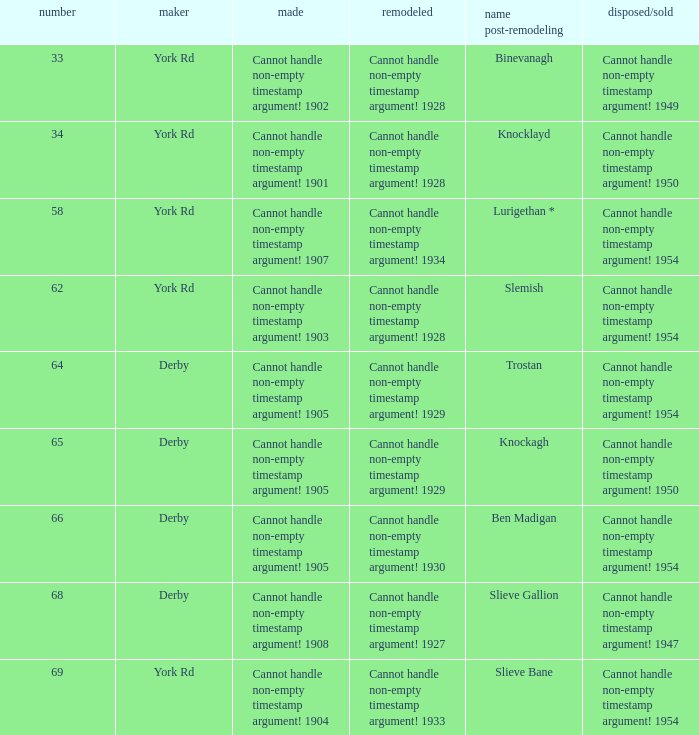Which Rebuilt has a Name as rebuilt of binevanagh? Cannot handle non-empty timestamp argument! 1928. 